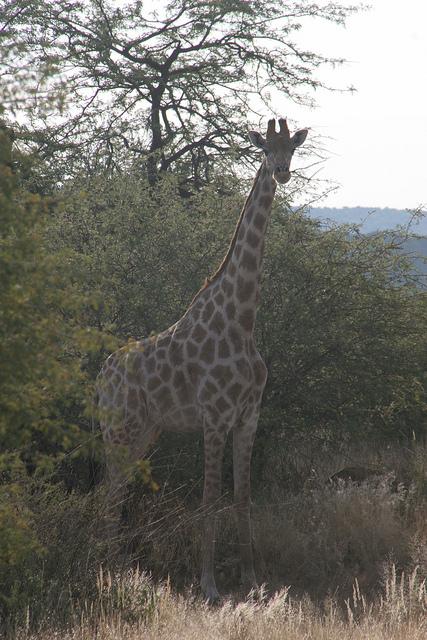Which zebra is a lighter color?
Answer briefly. 0. Is the giraffe standing in a natural environment?
Give a very brief answer. Yes. How many tree branches can be seen?
Keep it brief. Many. How many vehicles are in this photo?
Be succinct. 0. Is the giraffe walking?
Be succinct. No. Is the giraffe alone?
Write a very short answer. Yes. Is the giraffe in its natural habitat or captivity?
Keep it brief. Natural. Is this in the wild?
Quick response, please. Yes. Is this probably a scene in the wild?
Keep it brief. Yes. What number of giraffe are eating?
Give a very brief answer. 0. How many giraffes in the picture?
Quick response, please. 1. Where is the giraffe looking?
Give a very brief answer. At camera. How many giraffes are in this photo?
Be succinct. 1. Is this picture taken in the wild?
Answer briefly. Yes. Would these giraffe's be male or female?
Short answer required. Male. 